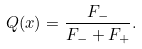Convert formula to latex. <formula><loc_0><loc_0><loc_500><loc_500>Q ( x ) = \frac { F _ { - } } { F _ { - } + F _ { + } } .</formula> 